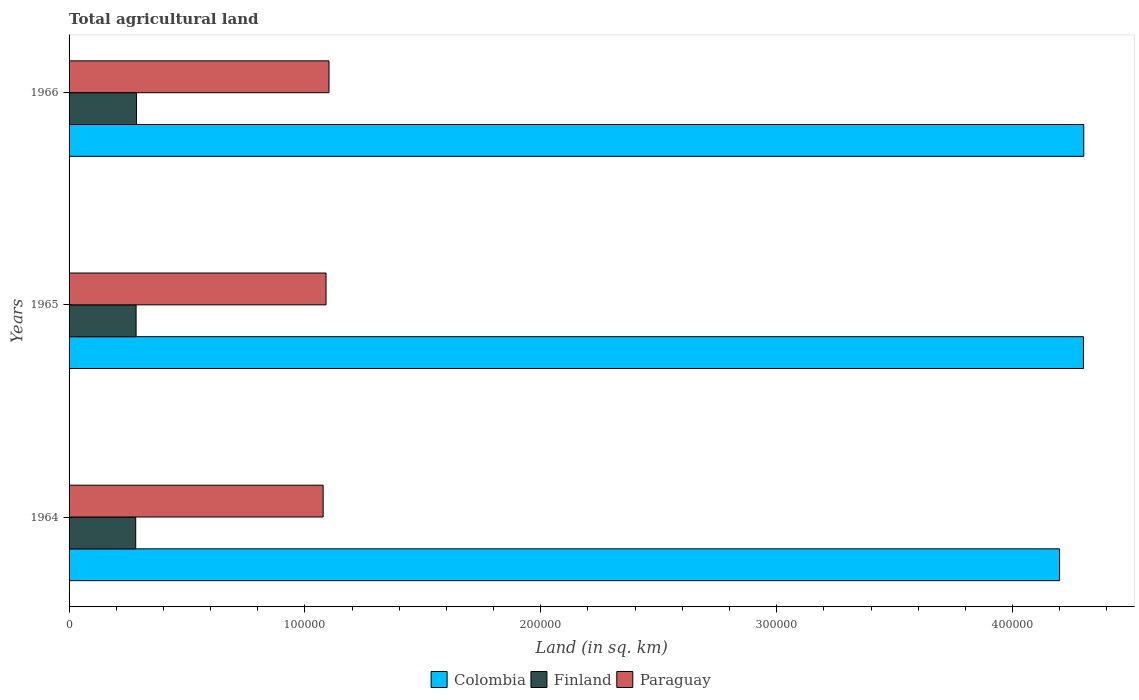How many different coloured bars are there?
Offer a terse response. 3. Are the number of bars per tick equal to the number of legend labels?
Offer a terse response. Yes. Are the number of bars on each tick of the Y-axis equal?
Keep it short and to the point. Yes. How many bars are there on the 3rd tick from the bottom?
Ensure brevity in your answer.  3. What is the label of the 3rd group of bars from the top?
Offer a terse response. 1964. In how many cases, is the number of bars for a given year not equal to the number of legend labels?
Provide a succinct answer. 0. What is the total agricultural land in Finland in 1966?
Give a very brief answer. 2.86e+04. Across all years, what is the maximum total agricultural land in Finland?
Provide a short and direct response. 2.86e+04. Across all years, what is the minimum total agricultural land in Colombia?
Your answer should be compact. 4.20e+05. In which year was the total agricultural land in Paraguay maximum?
Offer a terse response. 1966. In which year was the total agricultural land in Paraguay minimum?
Make the answer very short. 1964. What is the total total agricultural land in Paraguay in the graph?
Your answer should be compact. 3.27e+05. What is the difference between the total agricultural land in Colombia in 1964 and that in 1965?
Keep it short and to the point. -1.01e+04. What is the difference between the total agricultural land in Paraguay in 1966 and the total agricultural land in Colombia in 1965?
Provide a succinct answer. -3.20e+05. What is the average total agricultural land in Finland per year?
Give a very brief answer. 2.84e+04. In the year 1966, what is the difference between the total agricultural land in Colombia and total agricultural land in Finland?
Give a very brief answer. 4.02e+05. In how many years, is the total agricultural land in Finland greater than 100000 sq.km?
Provide a succinct answer. 0. What is the ratio of the total agricultural land in Finland in 1964 to that in 1966?
Offer a very short reply. 0.99. Is the difference between the total agricultural land in Colombia in 1964 and 1965 greater than the difference between the total agricultural land in Finland in 1964 and 1965?
Ensure brevity in your answer.  No. What is the difference between the highest and the second highest total agricultural land in Colombia?
Provide a succinct answer. 120. What is the difference between the highest and the lowest total agricultural land in Finland?
Make the answer very short. 338. In how many years, is the total agricultural land in Finland greater than the average total agricultural land in Finland taken over all years?
Make the answer very short. 1. What does the 3rd bar from the top in 1965 represents?
Keep it short and to the point. Colombia. Is it the case that in every year, the sum of the total agricultural land in Colombia and total agricultural land in Paraguay is greater than the total agricultural land in Finland?
Make the answer very short. Yes. Are all the bars in the graph horizontal?
Your answer should be compact. Yes. What is the difference between two consecutive major ticks on the X-axis?
Offer a terse response. 1.00e+05. Does the graph contain grids?
Ensure brevity in your answer.  No. Where does the legend appear in the graph?
Ensure brevity in your answer.  Bottom center. How many legend labels are there?
Your answer should be very brief. 3. How are the legend labels stacked?
Provide a succinct answer. Horizontal. What is the title of the graph?
Your answer should be compact. Total agricultural land. What is the label or title of the X-axis?
Make the answer very short. Land (in sq. km). What is the label or title of the Y-axis?
Keep it short and to the point. Years. What is the Land (in sq. km) of Colombia in 1964?
Make the answer very short. 4.20e+05. What is the Land (in sq. km) in Finland in 1964?
Offer a very short reply. 2.83e+04. What is the Land (in sq. km) in Paraguay in 1964?
Give a very brief answer. 1.08e+05. What is the Land (in sq. km) in Colombia in 1965?
Give a very brief answer. 4.30e+05. What is the Land (in sq. km) in Finland in 1965?
Your answer should be compact. 2.84e+04. What is the Land (in sq. km) of Paraguay in 1965?
Make the answer very short. 1.09e+05. What is the Land (in sq. km) in Colombia in 1966?
Keep it short and to the point. 4.30e+05. What is the Land (in sq. km) in Finland in 1966?
Offer a very short reply. 2.86e+04. What is the Land (in sq. km) in Paraguay in 1966?
Keep it short and to the point. 1.10e+05. Across all years, what is the maximum Land (in sq. km) in Colombia?
Your response must be concise. 4.30e+05. Across all years, what is the maximum Land (in sq. km) in Finland?
Provide a short and direct response. 2.86e+04. Across all years, what is the maximum Land (in sq. km) in Paraguay?
Keep it short and to the point. 1.10e+05. Across all years, what is the minimum Land (in sq. km) of Colombia?
Ensure brevity in your answer.  4.20e+05. Across all years, what is the minimum Land (in sq. km) in Finland?
Give a very brief answer. 2.83e+04. Across all years, what is the minimum Land (in sq. km) of Paraguay?
Offer a terse response. 1.08e+05. What is the total Land (in sq. km) of Colombia in the graph?
Make the answer very short. 1.28e+06. What is the total Land (in sq. km) of Finland in the graph?
Your answer should be very brief. 8.53e+04. What is the total Land (in sq. km) in Paraguay in the graph?
Offer a very short reply. 3.27e+05. What is the difference between the Land (in sq. km) of Colombia in 1964 and that in 1965?
Give a very brief answer. -1.01e+04. What is the difference between the Land (in sq. km) of Finland in 1964 and that in 1965?
Offer a terse response. -159. What is the difference between the Land (in sq. km) in Paraguay in 1964 and that in 1965?
Your response must be concise. -1230. What is the difference between the Land (in sq. km) of Colombia in 1964 and that in 1966?
Offer a very short reply. -1.02e+04. What is the difference between the Land (in sq. km) in Finland in 1964 and that in 1966?
Offer a terse response. -338. What is the difference between the Land (in sq. km) in Paraguay in 1964 and that in 1966?
Keep it short and to the point. -2480. What is the difference between the Land (in sq. km) of Colombia in 1965 and that in 1966?
Give a very brief answer. -120. What is the difference between the Land (in sq. km) of Finland in 1965 and that in 1966?
Your answer should be compact. -179. What is the difference between the Land (in sq. km) of Paraguay in 1965 and that in 1966?
Offer a terse response. -1250. What is the difference between the Land (in sq. km) in Colombia in 1964 and the Land (in sq. km) in Finland in 1965?
Make the answer very short. 3.92e+05. What is the difference between the Land (in sq. km) of Colombia in 1964 and the Land (in sq. km) of Paraguay in 1965?
Your answer should be compact. 3.11e+05. What is the difference between the Land (in sq. km) in Finland in 1964 and the Land (in sq. km) in Paraguay in 1965?
Ensure brevity in your answer.  -8.07e+04. What is the difference between the Land (in sq. km) of Colombia in 1964 and the Land (in sq. km) of Finland in 1966?
Provide a succinct answer. 3.91e+05. What is the difference between the Land (in sq. km) of Colombia in 1964 and the Land (in sq. km) of Paraguay in 1966?
Your response must be concise. 3.10e+05. What is the difference between the Land (in sq. km) of Finland in 1964 and the Land (in sq. km) of Paraguay in 1966?
Ensure brevity in your answer.  -8.19e+04. What is the difference between the Land (in sq. km) in Colombia in 1965 and the Land (in sq. km) in Finland in 1966?
Keep it short and to the point. 4.01e+05. What is the difference between the Land (in sq. km) in Colombia in 1965 and the Land (in sq. km) in Paraguay in 1966?
Ensure brevity in your answer.  3.20e+05. What is the difference between the Land (in sq. km) of Finland in 1965 and the Land (in sq. km) of Paraguay in 1966?
Ensure brevity in your answer.  -8.18e+04. What is the average Land (in sq. km) of Colombia per year?
Give a very brief answer. 4.27e+05. What is the average Land (in sq. km) in Finland per year?
Provide a succinct answer. 2.84e+04. What is the average Land (in sq. km) in Paraguay per year?
Ensure brevity in your answer.  1.09e+05. In the year 1964, what is the difference between the Land (in sq. km) in Colombia and Land (in sq. km) in Finland?
Your answer should be compact. 3.92e+05. In the year 1964, what is the difference between the Land (in sq. km) in Colombia and Land (in sq. km) in Paraguay?
Ensure brevity in your answer.  3.12e+05. In the year 1964, what is the difference between the Land (in sq. km) of Finland and Land (in sq. km) of Paraguay?
Your answer should be compact. -7.95e+04. In the year 1965, what is the difference between the Land (in sq. km) in Colombia and Land (in sq. km) in Finland?
Your answer should be very brief. 4.02e+05. In the year 1965, what is the difference between the Land (in sq. km) of Colombia and Land (in sq. km) of Paraguay?
Offer a terse response. 3.21e+05. In the year 1965, what is the difference between the Land (in sq. km) of Finland and Land (in sq. km) of Paraguay?
Your answer should be compact. -8.05e+04. In the year 1966, what is the difference between the Land (in sq. km) of Colombia and Land (in sq. km) of Finland?
Make the answer very short. 4.02e+05. In the year 1966, what is the difference between the Land (in sq. km) of Colombia and Land (in sq. km) of Paraguay?
Provide a short and direct response. 3.20e+05. In the year 1966, what is the difference between the Land (in sq. km) of Finland and Land (in sq. km) of Paraguay?
Ensure brevity in your answer.  -8.16e+04. What is the ratio of the Land (in sq. km) of Colombia in 1964 to that in 1965?
Offer a terse response. 0.98. What is the ratio of the Land (in sq. km) in Paraguay in 1964 to that in 1965?
Your answer should be compact. 0.99. What is the ratio of the Land (in sq. km) of Colombia in 1964 to that in 1966?
Provide a short and direct response. 0.98. What is the ratio of the Land (in sq. km) of Paraguay in 1964 to that in 1966?
Provide a succinct answer. 0.98. What is the ratio of the Land (in sq. km) in Paraguay in 1965 to that in 1966?
Your response must be concise. 0.99. What is the difference between the highest and the second highest Land (in sq. km) in Colombia?
Your response must be concise. 120. What is the difference between the highest and the second highest Land (in sq. km) in Finland?
Offer a terse response. 179. What is the difference between the highest and the second highest Land (in sq. km) of Paraguay?
Offer a very short reply. 1250. What is the difference between the highest and the lowest Land (in sq. km) in Colombia?
Offer a very short reply. 1.02e+04. What is the difference between the highest and the lowest Land (in sq. km) in Finland?
Ensure brevity in your answer.  338. What is the difference between the highest and the lowest Land (in sq. km) in Paraguay?
Offer a very short reply. 2480. 